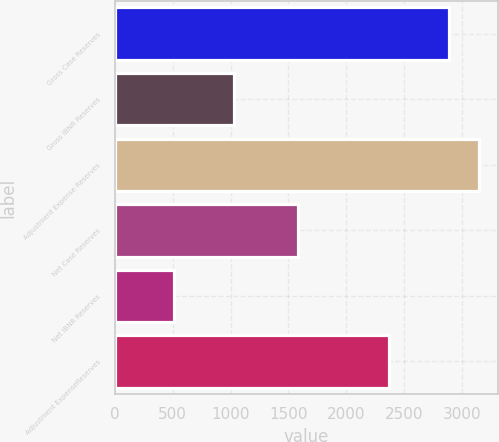<chart> <loc_0><loc_0><loc_500><loc_500><bar_chart><fcel>Gross Case Reserves<fcel>Gross IBNR Reserves<fcel>Adjustment Expense Reserves<fcel>Net Case Reserves<fcel>Net IBNR Reserves<fcel>Adjustment ExpenseReserves<nl><fcel>2889.5<fcel>1032.9<fcel>3150.8<fcel>1583<fcel>510.3<fcel>2366.9<nl></chart> 